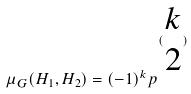<formula> <loc_0><loc_0><loc_500><loc_500>\mu _ { G } ( H _ { 1 } , H _ { 2 } ) = ( - 1 ) ^ { k } p ^ { ( \begin{matrix} k \\ 2 \end{matrix} ) }</formula> 